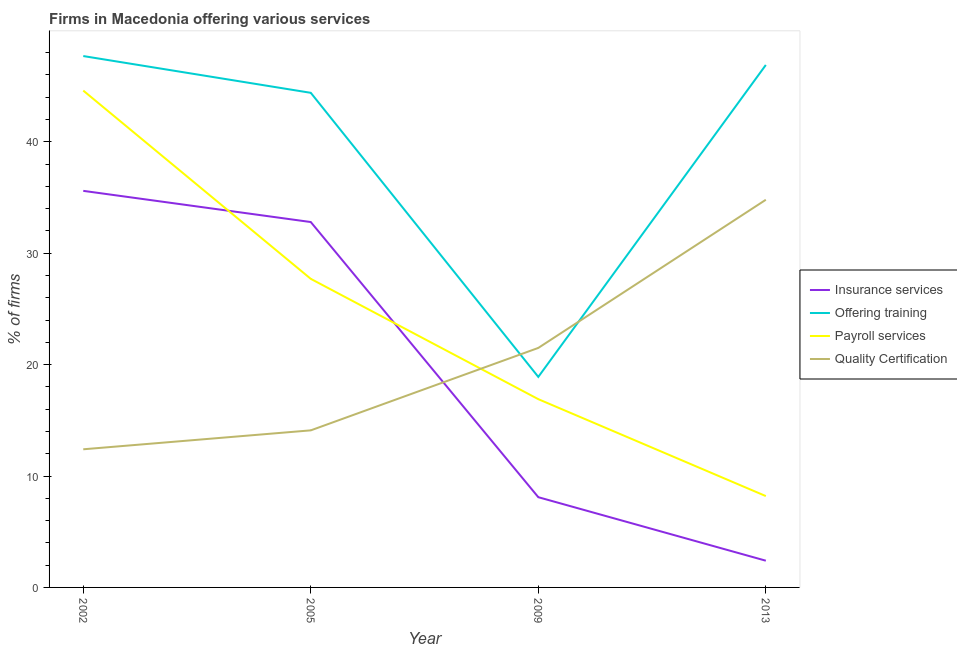Is the number of lines equal to the number of legend labels?
Provide a succinct answer. Yes. What is the percentage of firms offering quality certification in 2009?
Offer a terse response. 21.5. Across all years, what is the maximum percentage of firms offering insurance services?
Your answer should be very brief. 35.6. Across all years, what is the minimum percentage of firms offering quality certification?
Your response must be concise. 12.4. In which year was the percentage of firms offering training minimum?
Provide a succinct answer. 2009. What is the total percentage of firms offering payroll services in the graph?
Give a very brief answer. 97.4. What is the difference between the percentage of firms offering training in 2005 and that in 2009?
Your answer should be very brief. 25.5. What is the difference between the percentage of firms offering payroll services in 2002 and the percentage of firms offering insurance services in 2013?
Keep it short and to the point. 42.2. What is the average percentage of firms offering quality certification per year?
Your response must be concise. 20.7. In the year 2005, what is the difference between the percentage of firms offering quality certification and percentage of firms offering payroll services?
Give a very brief answer. -13.6. In how many years, is the percentage of firms offering payroll services greater than 44 %?
Offer a terse response. 1. What is the ratio of the percentage of firms offering payroll services in 2002 to that in 2009?
Your answer should be very brief. 2.64. Is the percentage of firms offering quality certification in 2005 less than that in 2013?
Your answer should be very brief. Yes. Is the difference between the percentage of firms offering insurance services in 2005 and 2013 greater than the difference between the percentage of firms offering training in 2005 and 2013?
Make the answer very short. Yes. What is the difference between the highest and the second highest percentage of firms offering payroll services?
Your answer should be compact. 16.9. What is the difference between the highest and the lowest percentage of firms offering insurance services?
Ensure brevity in your answer.  33.2. In how many years, is the percentage of firms offering payroll services greater than the average percentage of firms offering payroll services taken over all years?
Offer a terse response. 2. Is the sum of the percentage of firms offering insurance services in 2002 and 2009 greater than the maximum percentage of firms offering quality certification across all years?
Give a very brief answer. Yes. Is it the case that in every year, the sum of the percentage of firms offering insurance services and percentage of firms offering training is greater than the percentage of firms offering payroll services?
Keep it short and to the point. Yes. Does the percentage of firms offering training monotonically increase over the years?
Give a very brief answer. No. Is the percentage of firms offering insurance services strictly greater than the percentage of firms offering training over the years?
Your answer should be very brief. No. Is the percentage of firms offering payroll services strictly less than the percentage of firms offering quality certification over the years?
Provide a succinct answer. No. How many lines are there?
Keep it short and to the point. 4. Are the values on the major ticks of Y-axis written in scientific E-notation?
Keep it short and to the point. No. Does the graph contain any zero values?
Your answer should be very brief. No. Does the graph contain grids?
Offer a very short reply. No. Where does the legend appear in the graph?
Ensure brevity in your answer.  Center right. How are the legend labels stacked?
Provide a succinct answer. Vertical. What is the title of the graph?
Your answer should be compact. Firms in Macedonia offering various services . What is the label or title of the X-axis?
Your answer should be very brief. Year. What is the label or title of the Y-axis?
Your response must be concise. % of firms. What is the % of firms of Insurance services in 2002?
Offer a very short reply. 35.6. What is the % of firms in Offering training in 2002?
Ensure brevity in your answer.  47.7. What is the % of firms of Payroll services in 2002?
Provide a short and direct response. 44.6. What is the % of firms of Quality Certification in 2002?
Your response must be concise. 12.4. What is the % of firms in Insurance services in 2005?
Your answer should be very brief. 32.8. What is the % of firms in Offering training in 2005?
Make the answer very short. 44.4. What is the % of firms of Payroll services in 2005?
Offer a very short reply. 27.7. What is the % of firms in Quality Certification in 2005?
Keep it short and to the point. 14.1. What is the % of firms in Insurance services in 2009?
Your answer should be compact. 8.1. What is the % of firms in Payroll services in 2009?
Provide a succinct answer. 16.9. What is the % of firms in Quality Certification in 2009?
Your answer should be very brief. 21.5. What is the % of firms of Offering training in 2013?
Your answer should be compact. 46.9. What is the % of firms in Quality Certification in 2013?
Provide a short and direct response. 34.8. Across all years, what is the maximum % of firms of Insurance services?
Offer a very short reply. 35.6. Across all years, what is the maximum % of firms in Offering training?
Offer a terse response. 47.7. Across all years, what is the maximum % of firms in Payroll services?
Offer a very short reply. 44.6. Across all years, what is the maximum % of firms of Quality Certification?
Make the answer very short. 34.8. Across all years, what is the minimum % of firms in Payroll services?
Provide a short and direct response. 8.2. Across all years, what is the minimum % of firms in Quality Certification?
Your response must be concise. 12.4. What is the total % of firms in Insurance services in the graph?
Offer a terse response. 78.9. What is the total % of firms of Offering training in the graph?
Make the answer very short. 157.9. What is the total % of firms in Payroll services in the graph?
Offer a terse response. 97.4. What is the total % of firms in Quality Certification in the graph?
Your answer should be compact. 82.8. What is the difference between the % of firms in Offering training in 2002 and that in 2005?
Your answer should be compact. 3.3. What is the difference between the % of firms of Payroll services in 2002 and that in 2005?
Ensure brevity in your answer.  16.9. What is the difference between the % of firms in Quality Certification in 2002 and that in 2005?
Your answer should be compact. -1.7. What is the difference between the % of firms of Offering training in 2002 and that in 2009?
Provide a short and direct response. 28.8. What is the difference between the % of firms of Payroll services in 2002 and that in 2009?
Your response must be concise. 27.7. What is the difference between the % of firms of Insurance services in 2002 and that in 2013?
Give a very brief answer. 33.2. What is the difference between the % of firms of Offering training in 2002 and that in 2013?
Ensure brevity in your answer.  0.8. What is the difference between the % of firms of Payroll services in 2002 and that in 2013?
Your response must be concise. 36.4. What is the difference between the % of firms of Quality Certification in 2002 and that in 2013?
Your answer should be very brief. -22.4. What is the difference between the % of firms of Insurance services in 2005 and that in 2009?
Provide a succinct answer. 24.7. What is the difference between the % of firms in Quality Certification in 2005 and that in 2009?
Your response must be concise. -7.4. What is the difference between the % of firms of Insurance services in 2005 and that in 2013?
Keep it short and to the point. 30.4. What is the difference between the % of firms of Quality Certification in 2005 and that in 2013?
Your response must be concise. -20.7. What is the difference between the % of firms of Insurance services in 2009 and that in 2013?
Your response must be concise. 5.7. What is the difference between the % of firms in Offering training in 2009 and that in 2013?
Offer a very short reply. -28. What is the difference between the % of firms of Quality Certification in 2009 and that in 2013?
Your answer should be compact. -13.3. What is the difference between the % of firms of Insurance services in 2002 and the % of firms of Offering training in 2005?
Your response must be concise. -8.8. What is the difference between the % of firms of Insurance services in 2002 and the % of firms of Payroll services in 2005?
Provide a succinct answer. 7.9. What is the difference between the % of firms of Insurance services in 2002 and the % of firms of Quality Certification in 2005?
Offer a terse response. 21.5. What is the difference between the % of firms of Offering training in 2002 and the % of firms of Quality Certification in 2005?
Keep it short and to the point. 33.6. What is the difference between the % of firms of Payroll services in 2002 and the % of firms of Quality Certification in 2005?
Ensure brevity in your answer.  30.5. What is the difference between the % of firms in Insurance services in 2002 and the % of firms in Offering training in 2009?
Your answer should be very brief. 16.7. What is the difference between the % of firms of Insurance services in 2002 and the % of firms of Quality Certification in 2009?
Ensure brevity in your answer.  14.1. What is the difference between the % of firms in Offering training in 2002 and the % of firms in Payroll services in 2009?
Your answer should be very brief. 30.8. What is the difference between the % of firms in Offering training in 2002 and the % of firms in Quality Certification in 2009?
Your response must be concise. 26.2. What is the difference between the % of firms of Payroll services in 2002 and the % of firms of Quality Certification in 2009?
Provide a short and direct response. 23.1. What is the difference between the % of firms in Insurance services in 2002 and the % of firms in Payroll services in 2013?
Make the answer very short. 27.4. What is the difference between the % of firms of Offering training in 2002 and the % of firms of Payroll services in 2013?
Your answer should be very brief. 39.5. What is the difference between the % of firms in Insurance services in 2005 and the % of firms in Offering training in 2009?
Ensure brevity in your answer.  13.9. What is the difference between the % of firms of Insurance services in 2005 and the % of firms of Quality Certification in 2009?
Offer a terse response. 11.3. What is the difference between the % of firms of Offering training in 2005 and the % of firms of Quality Certification in 2009?
Give a very brief answer. 22.9. What is the difference between the % of firms of Payroll services in 2005 and the % of firms of Quality Certification in 2009?
Give a very brief answer. 6.2. What is the difference between the % of firms in Insurance services in 2005 and the % of firms in Offering training in 2013?
Make the answer very short. -14.1. What is the difference between the % of firms of Insurance services in 2005 and the % of firms of Payroll services in 2013?
Provide a short and direct response. 24.6. What is the difference between the % of firms of Insurance services in 2005 and the % of firms of Quality Certification in 2013?
Your answer should be very brief. -2. What is the difference between the % of firms in Offering training in 2005 and the % of firms in Payroll services in 2013?
Your answer should be compact. 36.2. What is the difference between the % of firms of Offering training in 2005 and the % of firms of Quality Certification in 2013?
Provide a succinct answer. 9.6. What is the difference between the % of firms of Payroll services in 2005 and the % of firms of Quality Certification in 2013?
Offer a very short reply. -7.1. What is the difference between the % of firms of Insurance services in 2009 and the % of firms of Offering training in 2013?
Make the answer very short. -38.8. What is the difference between the % of firms in Insurance services in 2009 and the % of firms in Quality Certification in 2013?
Your answer should be compact. -26.7. What is the difference between the % of firms in Offering training in 2009 and the % of firms in Payroll services in 2013?
Keep it short and to the point. 10.7. What is the difference between the % of firms of Offering training in 2009 and the % of firms of Quality Certification in 2013?
Give a very brief answer. -15.9. What is the difference between the % of firms of Payroll services in 2009 and the % of firms of Quality Certification in 2013?
Your answer should be compact. -17.9. What is the average % of firms of Insurance services per year?
Keep it short and to the point. 19.73. What is the average % of firms of Offering training per year?
Your answer should be very brief. 39.48. What is the average % of firms in Payroll services per year?
Keep it short and to the point. 24.35. What is the average % of firms of Quality Certification per year?
Provide a succinct answer. 20.7. In the year 2002, what is the difference between the % of firms in Insurance services and % of firms in Offering training?
Provide a short and direct response. -12.1. In the year 2002, what is the difference between the % of firms in Insurance services and % of firms in Quality Certification?
Your response must be concise. 23.2. In the year 2002, what is the difference between the % of firms of Offering training and % of firms of Quality Certification?
Your answer should be very brief. 35.3. In the year 2002, what is the difference between the % of firms of Payroll services and % of firms of Quality Certification?
Give a very brief answer. 32.2. In the year 2005, what is the difference between the % of firms in Insurance services and % of firms in Offering training?
Make the answer very short. -11.6. In the year 2005, what is the difference between the % of firms in Offering training and % of firms in Quality Certification?
Ensure brevity in your answer.  30.3. In the year 2005, what is the difference between the % of firms of Payroll services and % of firms of Quality Certification?
Provide a succinct answer. 13.6. In the year 2009, what is the difference between the % of firms in Insurance services and % of firms in Payroll services?
Your answer should be compact. -8.8. In the year 2009, what is the difference between the % of firms in Offering training and % of firms in Quality Certification?
Keep it short and to the point. -2.6. In the year 2013, what is the difference between the % of firms of Insurance services and % of firms of Offering training?
Give a very brief answer. -44.5. In the year 2013, what is the difference between the % of firms in Insurance services and % of firms in Payroll services?
Your answer should be very brief. -5.8. In the year 2013, what is the difference between the % of firms of Insurance services and % of firms of Quality Certification?
Offer a terse response. -32.4. In the year 2013, what is the difference between the % of firms in Offering training and % of firms in Payroll services?
Make the answer very short. 38.7. In the year 2013, what is the difference between the % of firms in Offering training and % of firms in Quality Certification?
Your response must be concise. 12.1. In the year 2013, what is the difference between the % of firms of Payroll services and % of firms of Quality Certification?
Give a very brief answer. -26.6. What is the ratio of the % of firms of Insurance services in 2002 to that in 2005?
Make the answer very short. 1.09. What is the ratio of the % of firms of Offering training in 2002 to that in 2005?
Ensure brevity in your answer.  1.07. What is the ratio of the % of firms in Payroll services in 2002 to that in 2005?
Your answer should be compact. 1.61. What is the ratio of the % of firms of Quality Certification in 2002 to that in 2005?
Provide a succinct answer. 0.88. What is the ratio of the % of firms of Insurance services in 2002 to that in 2009?
Your response must be concise. 4.4. What is the ratio of the % of firms in Offering training in 2002 to that in 2009?
Offer a terse response. 2.52. What is the ratio of the % of firms of Payroll services in 2002 to that in 2009?
Make the answer very short. 2.64. What is the ratio of the % of firms in Quality Certification in 2002 to that in 2009?
Give a very brief answer. 0.58. What is the ratio of the % of firms of Insurance services in 2002 to that in 2013?
Give a very brief answer. 14.83. What is the ratio of the % of firms of Offering training in 2002 to that in 2013?
Offer a very short reply. 1.02. What is the ratio of the % of firms of Payroll services in 2002 to that in 2013?
Give a very brief answer. 5.44. What is the ratio of the % of firms in Quality Certification in 2002 to that in 2013?
Offer a terse response. 0.36. What is the ratio of the % of firms in Insurance services in 2005 to that in 2009?
Give a very brief answer. 4.05. What is the ratio of the % of firms in Offering training in 2005 to that in 2009?
Offer a very short reply. 2.35. What is the ratio of the % of firms in Payroll services in 2005 to that in 2009?
Your response must be concise. 1.64. What is the ratio of the % of firms of Quality Certification in 2005 to that in 2009?
Make the answer very short. 0.66. What is the ratio of the % of firms in Insurance services in 2005 to that in 2013?
Ensure brevity in your answer.  13.67. What is the ratio of the % of firms of Offering training in 2005 to that in 2013?
Keep it short and to the point. 0.95. What is the ratio of the % of firms in Payroll services in 2005 to that in 2013?
Make the answer very short. 3.38. What is the ratio of the % of firms of Quality Certification in 2005 to that in 2013?
Provide a succinct answer. 0.41. What is the ratio of the % of firms of Insurance services in 2009 to that in 2013?
Your answer should be very brief. 3.38. What is the ratio of the % of firms in Offering training in 2009 to that in 2013?
Offer a very short reply. 0.4. What is the ratio of the % of firms in Payroll services in 2009 to that in 2013?
Keep it short and to the point. 2.06. What is the ratio of the % of firms in Quality Certification in 2009 to that in 2013?
Provide a succinct answer. 0.62. What is the difference between the highest and the second highest % of firms of Insurance services?
Provide a short and direct response. 2.8. What is the difference between the highest and the second highest % of firms of Quality Certification?
Keep it short and to the point. 13.3. What is the difference between the highest and the lowest % of firms of Insurance services?
Provide a short and direct response. 33.2. What is the difference between the highest and the lowest % of firms of Offering training?
Your answer should be compact. 28.8. What is the difference between the highest and the lowest % of firms in Payroll services?
Your answer should be compact. 36.4. What is the difference between the highest and the lowest % of firms in Quality Certification?
Offer a terse response. 22.4. 